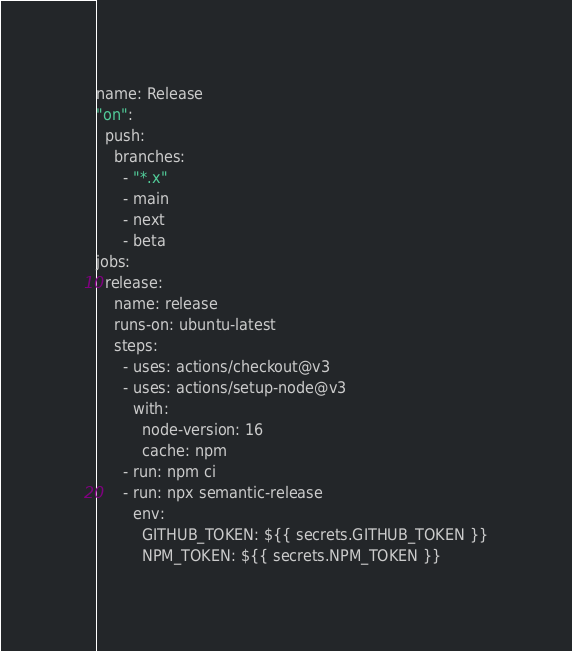<code> <loc_0><loc_0><loc_500><loc_500><_YAML_>name: Release
"on":
  push:
    branches:
      - "*.x"
      - main
      - next
      - beta
jobs:
  release:
    name: release
    runs-on: ubuntu-latest
    steps:
      - uses: actions/checkout@v3
      - uses: actions/setup-node@v3
        with:
          node-version: 16
          cache: npm
      - run: npm ci
      - run: npx semantic-release
        env:
          GITHUB_TOKEN: ${{ secrets.GITHUB_TOKEN }}
          NPM_TOKEN: ${{ secrets.NPM_TOKEN }}
</code> 